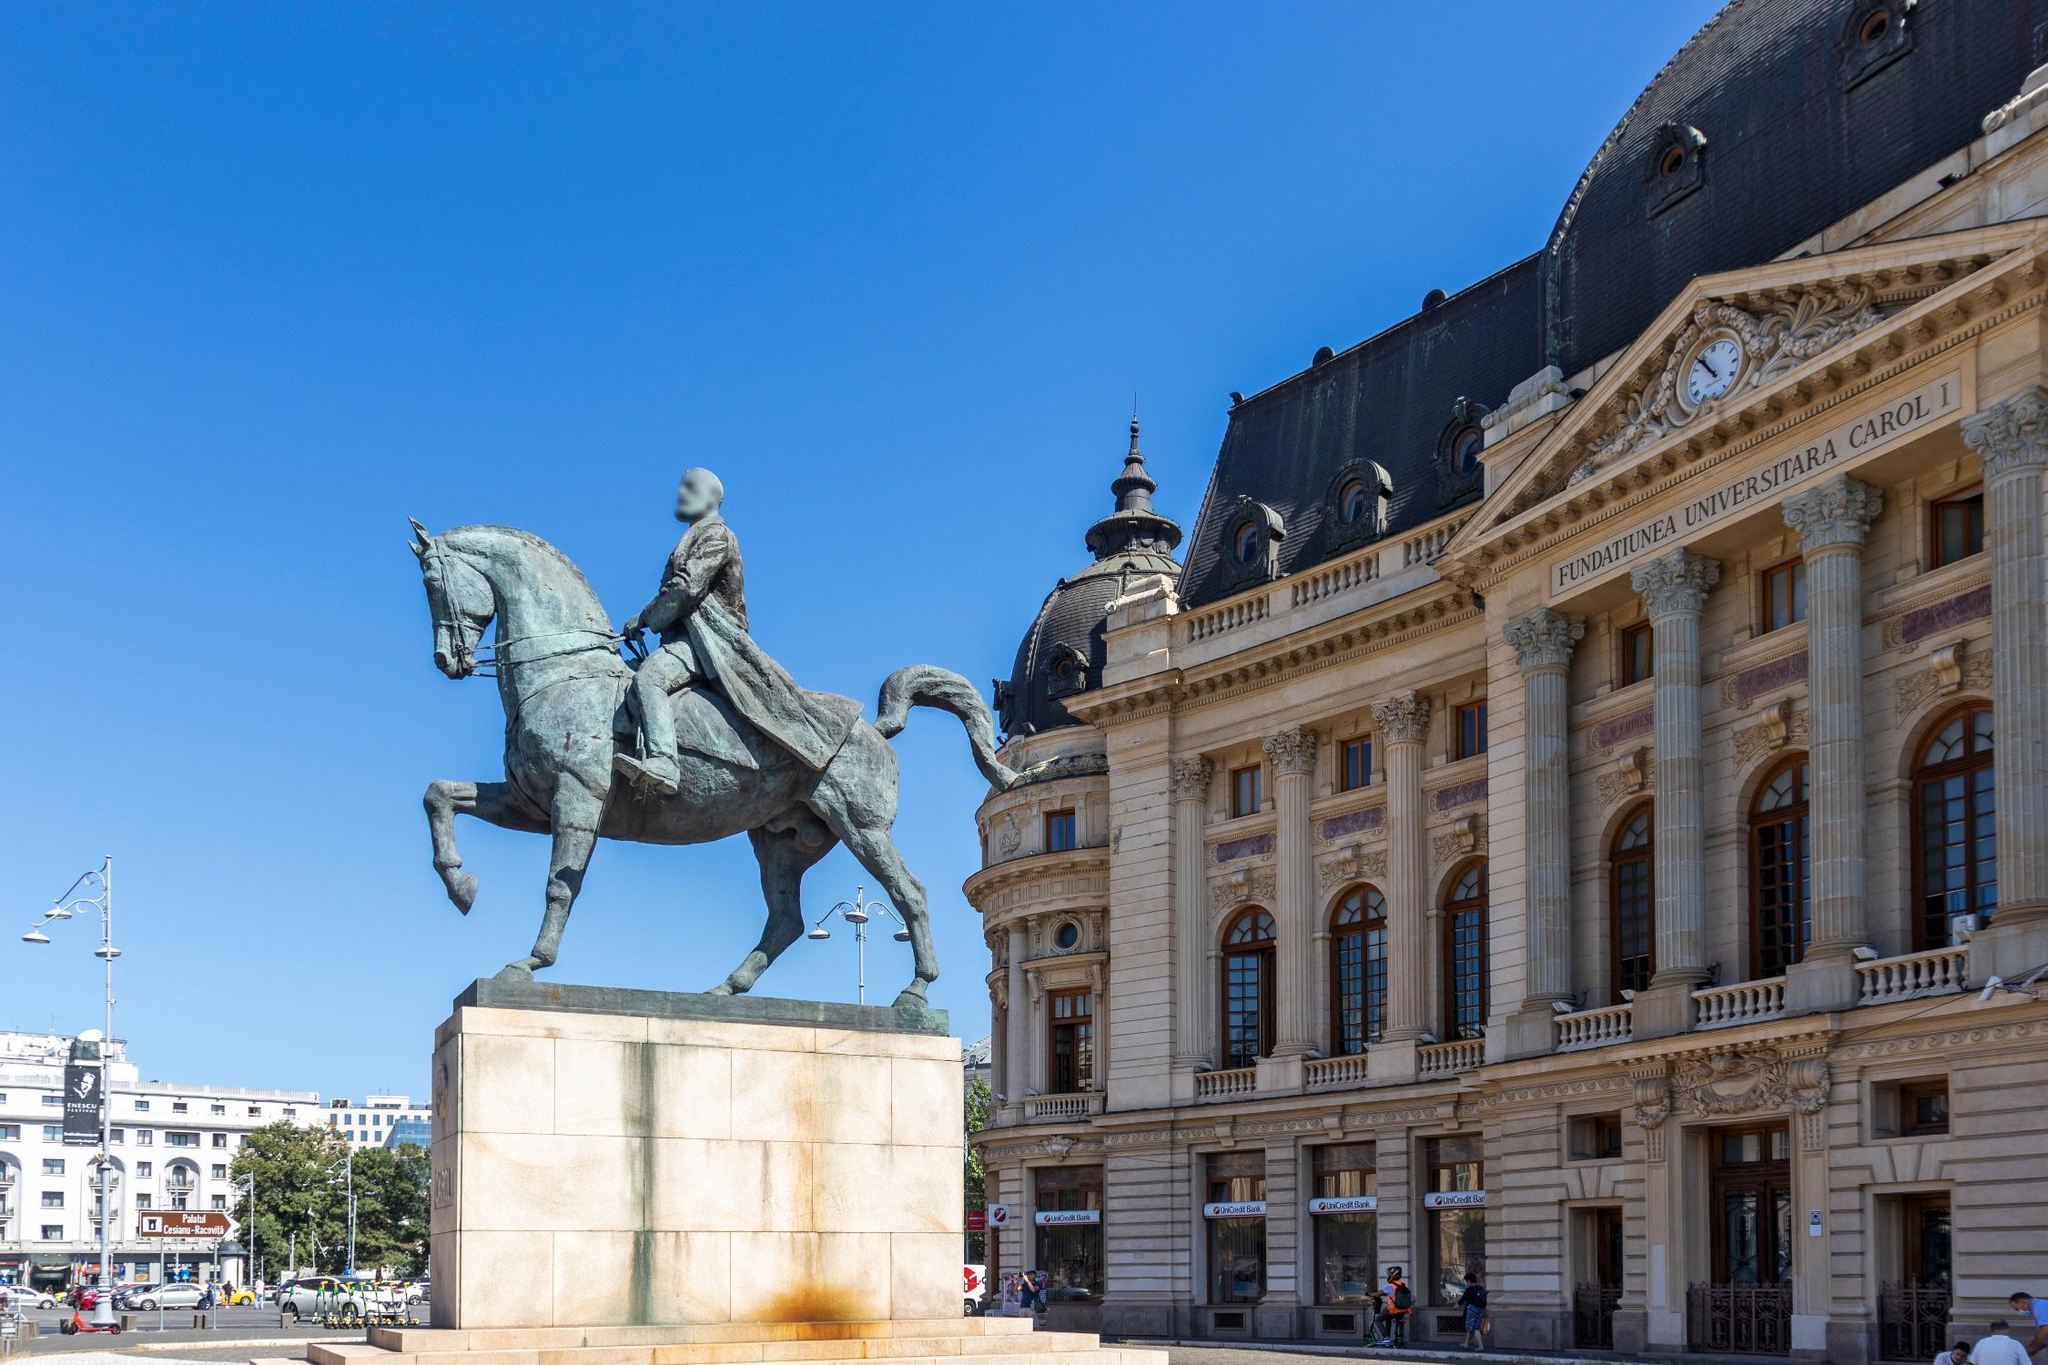Can you describe the main features of this image for me? The image depicts a striking scene featuring an impressive equestrian statue prominently positioned in front of a grand building. The statue showcases a man on a rearing horse, captured in a moment of dynamic action. The man appears to be a figure of historical significance or authority, as he raises a sword triumphantly in his right hand while holding the reins with his left. The horse's pose, with its front legs elevated and back legs grounded on a raised pedestal, adds a sense of motion and drama.

The backdrop is equally noteworthy, with a large, finely detailed building that boasts neoclassical architectural elements, including columns and a curved facade. A notable dome on the right side of the building enhances its majestic appearance. Above, the sky is a clear and vibrant blue, providing a serene contrast to the animated scene below.

Surrounding the area, there are trees and distant figures of people, which add a sense of scale and liveliness to the overall composition. This juxtaposition of the dynamic statue and the historical architectural grandeur creates a visually captivating and narrative-rich scene, reflecting a moment frozen in time, embodying historical triumph and architectural splendor. 